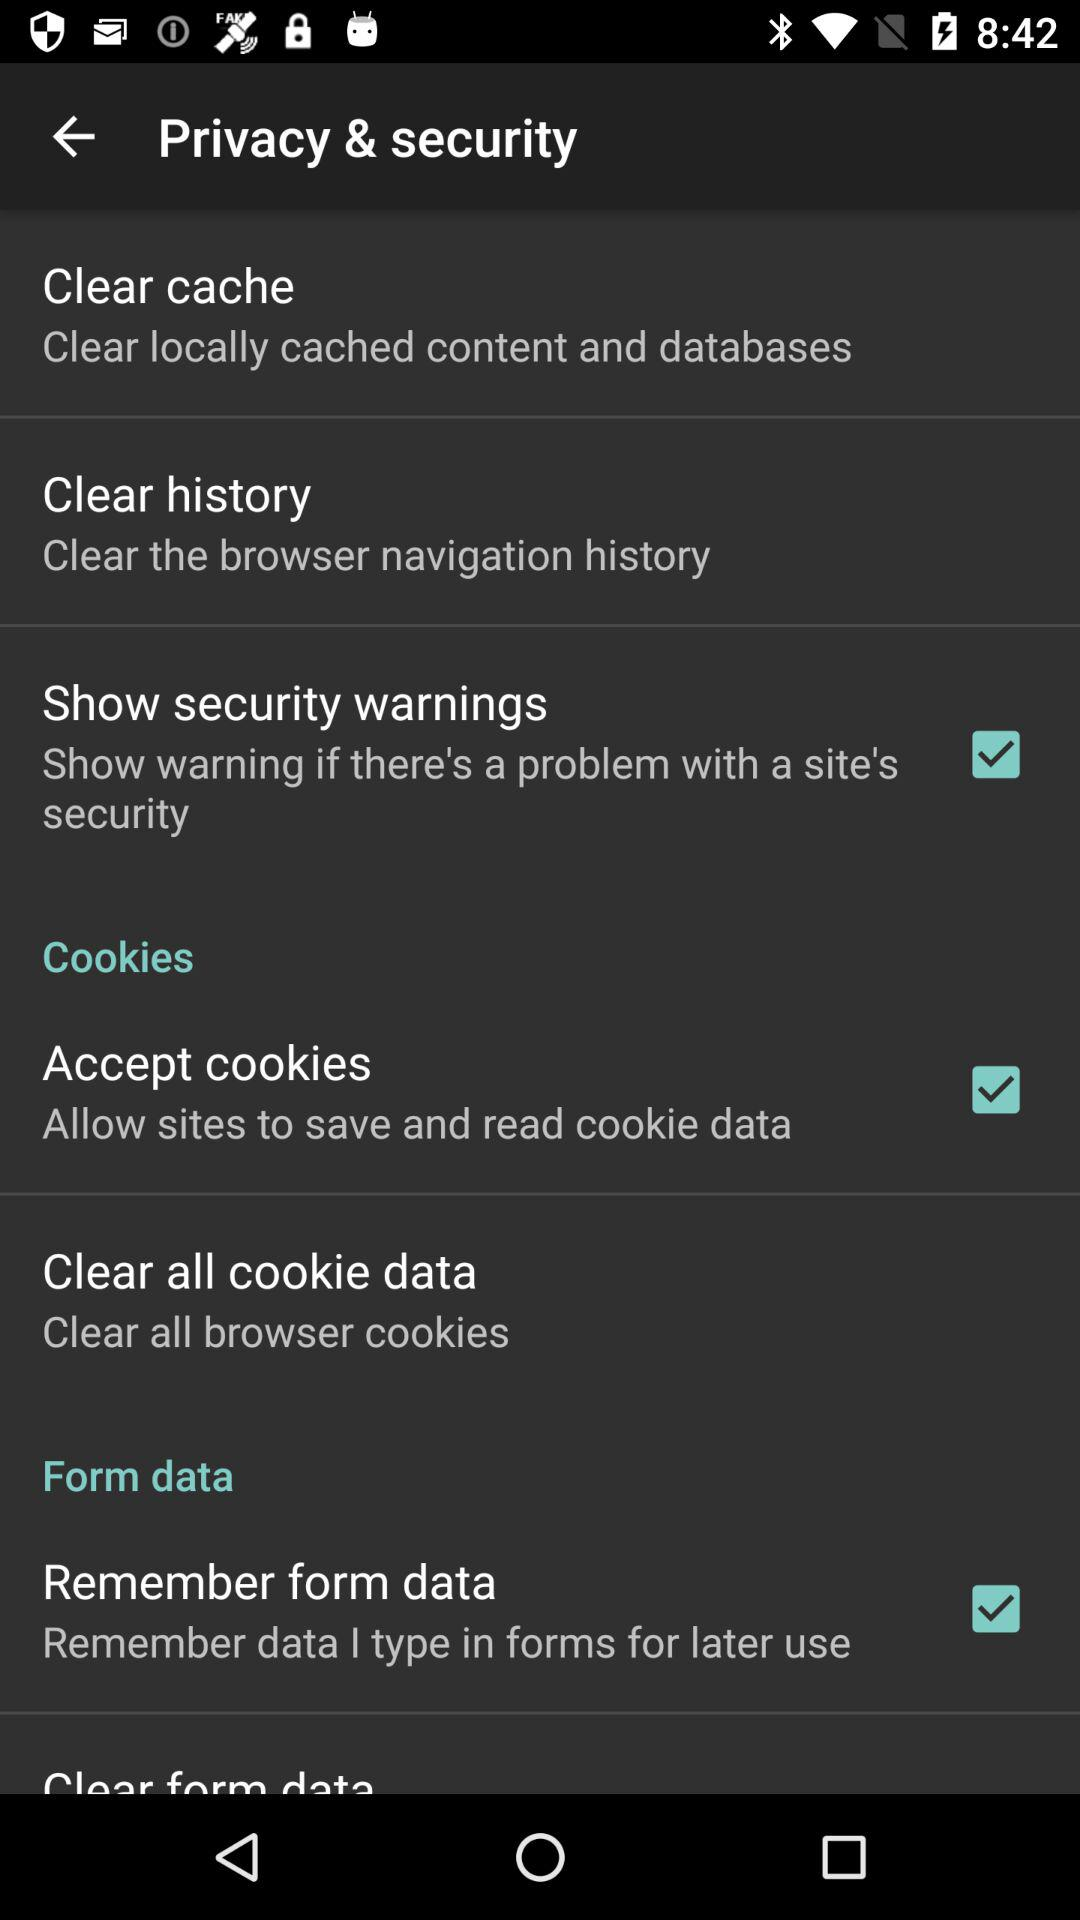What is the status of "Accept cookies"? The status is "on". 